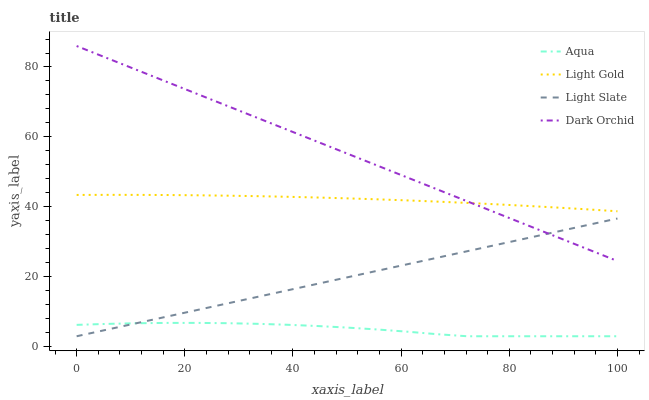Does Aqua have the minimum area under the curve?
Answer yes or no. Yes. Does Dark Orchid have the maximum area under the curve?
Answer yes or no. Yes. Does Light Gold have the minimum area under the curve?
Answer yes or no. No. Does Light Gold have the maximum area under the curve?
Answer yes or no. No. Is Light Slate the smoothest?
Answer yes or no. Yes. Is Aqua the roughest?
Answer yes or no. Yes. Is Light Gold the smoothest?
Answer yes or no. No. Is Light Gold the roughest?
Answer yes or no. No. Does Light Slate have the lowest value?
Answer yes or no. Yes. Does Light Gold have the lowest value?
Answer yes or no. No. Does Dark Orchid have the highest value?
Answer yes or no. Yes. Does Light Gold have the highest value?
Answer yes or no. No. Is Light Slate less than Light Gold?
Answer yes or no. Yes. Is Light Gold greater than Aqua?
Answer yes or no. Yes. Does Dark Orchid intersect Light Gold?
Answer yes or no. Yes. Is Dark Orchid less than Light Gold?
Answer yes or no. No. Is Dark Orchid greater than Light Gold?
Answer yes or no. No. Does Light Slate intersect Light Gold?
Answer yes or no. No. 